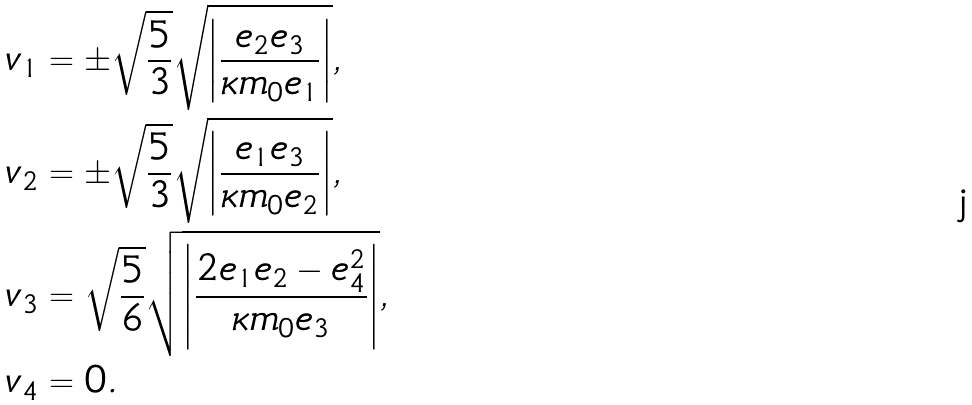Convert formula to latex. <formula><loc_0><loc_0><loc_500><loc_500>v _ { 1 } & = \pm \sqrt { \frac { 5 } { 3 } } \sqrt { \left | \frac { e _ { 2 } e _ { 3 } } { \kappa m _ { 0 } e _ { 1 } } \right | } , \\ v _ { 2 } & = \pm \sqrt { \frac { 5 } { 3 } } \sqrt { \left | \frac { e _ { 1 } e _ { 3 } } { \kappa m _ { 0 } e _ { 2 } } \right | } , \\ v _ { 3 } & = \sqrt { \frac { 5 } { 6 } } \sqrt { \left | \frac { 2 e _ { 1 } e _ { 2 } - e _ { 4 } ^ { 2 } } { \kappa m _ { 0 } e _ { 3 } } \right | } , \\ v _ { 4 } & = 0 .</formula> 